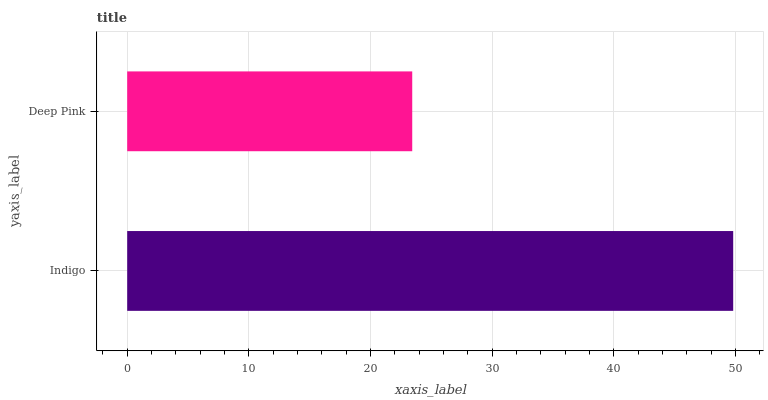Is Deep Pink the minimum?
Answer yes or no. Yes. Is Indigo the maximum?
Answer yes or no. Yes. Is Deep Pink the maximum?
Answer yes or no. No. Is Indigo greater than Deep Pink?
Answer yes or no. Yes. Is Deep Pink less than Indigo?
Answer yes or no. Yes. Is Deep Pink greater than Indigo?
Answer yes or no. No. Is Indigo less than Deep Pink?
Answer yes or no. No. Is Indigo the high median?
Answer yes or no. Yes. Is Deep Pink the low median?
Answer yes or no. Yes. Is Deep Pink the high median?
Answer yes or no. No. Is Indigo the low median?
Answer yes or no. No. 